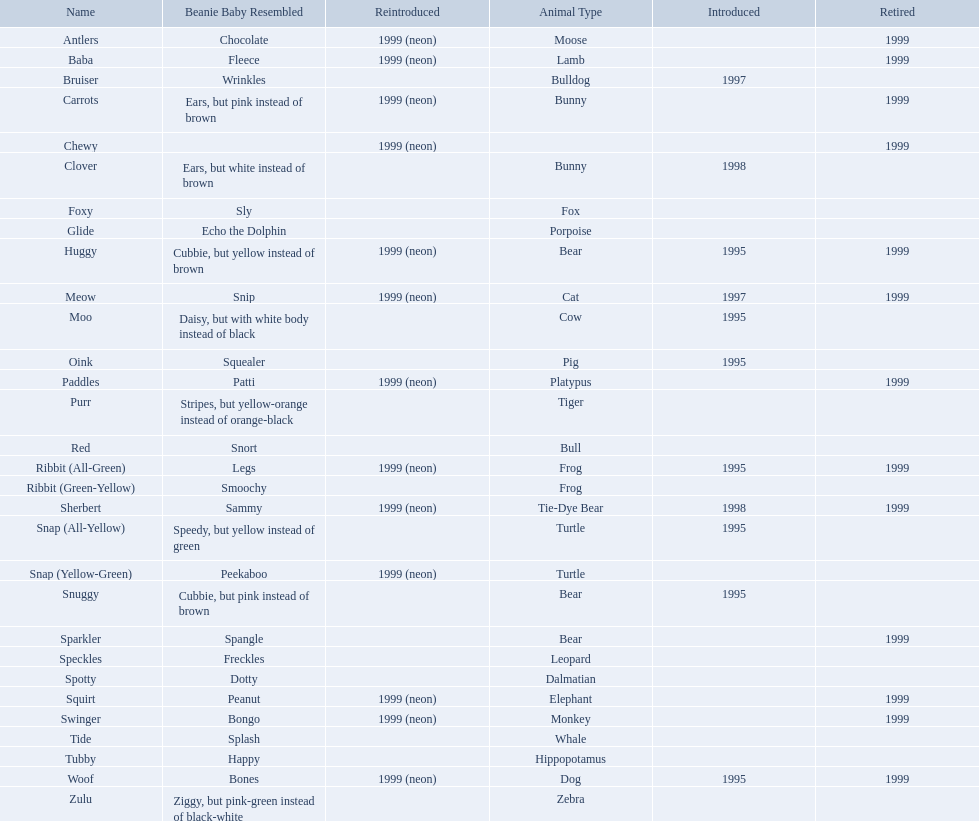What are all the different names of the pillow pals? Antlers, Baba, Bruiser, Carrots, Chewy, Clover, Foxy, Glide, Huggy, Meow, Moo, Oink, Paddles, Purr, Red, Ribbit (All-Green), Ribbit (Green-Yellow), Sherbert, Snap (All-Yellow), Snap (Yellow-Green), Snuggy, Sparkler, Speckles, Spotty, Squirt, Swinger, Tide, Tubby, Woof, Zulu. Which of these are a dalmatian? Spotty. 